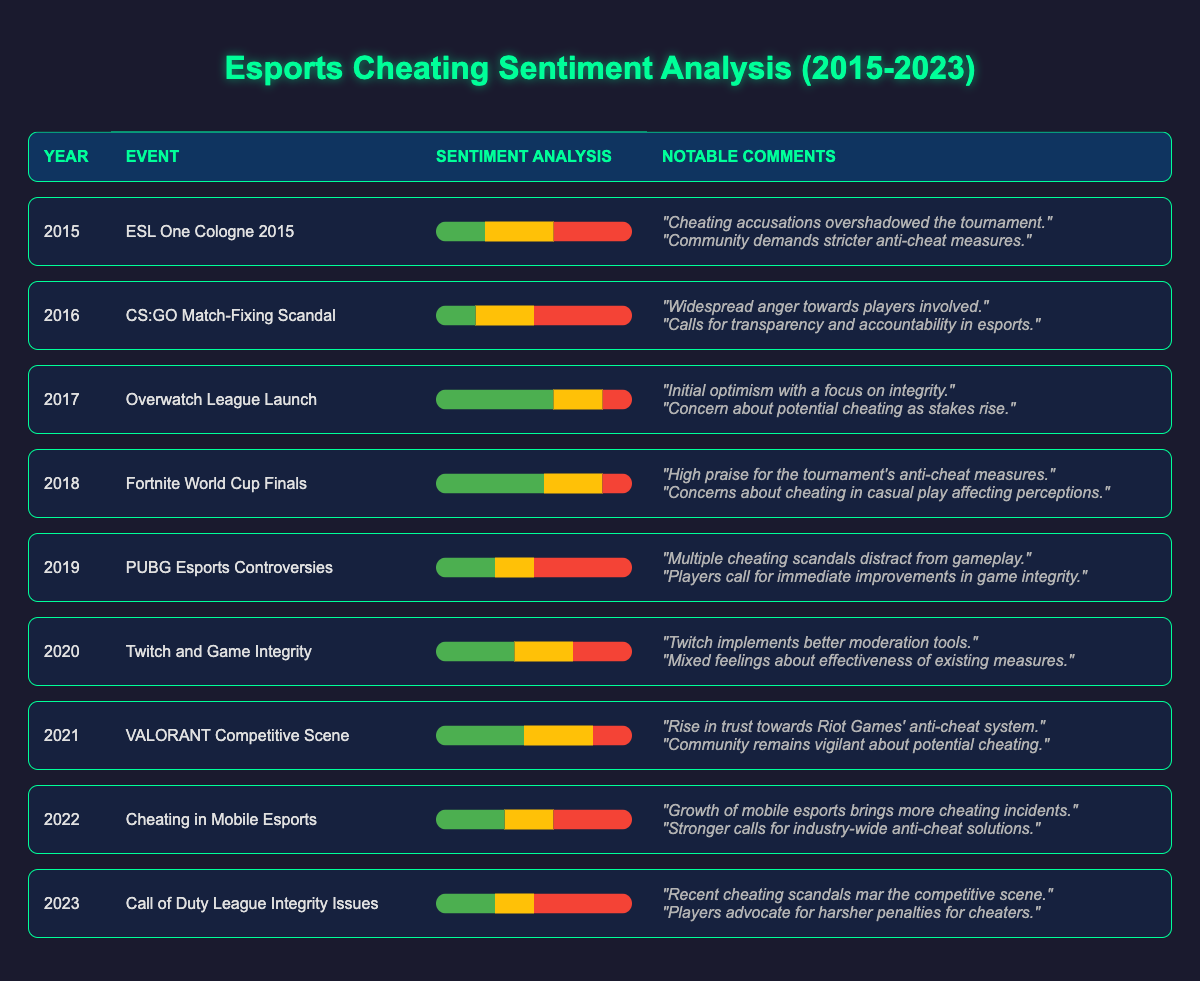What was the negative sentiment percentage in 2015? According to the table, the negative sentiment for the year 2015 (ESL One Cologne 2015) is explicitly stated as 40%.
Answer: 40% Which event in 2017 received the highest positive sentiment? The event in 2017 is the Overwatch League Launch, which had a positive sentiment of 60%, the highest in that year compared to other events.
Answer: Overwatch League Launch What was the overall trend in negative sentiment from 2015 to 2023? The negative sentiment increased from 40% in 2015, peaked to 50% in 2016, and fluctuated between 15% to 50%, ending at 50% in 2023.
Answer: It fluctuated, ending at 50% What is the average positive sentiment over the years from 2015 to 2023? To find the average, sum the positive sentiments: (25 + 20 + 60 + 55 + 30 + 40 + 45 + 35 + 30) = 370. There are 9 years total, so the average is 370 / 9 = approximately 41.11.
Answer: Approximately 41.11 Which year saw a decrease in positive sentiment compared to the previous year? In 2019, positive sentiment decreased to 30% from 55% in 2018, thus marking a decrease.
Answer: 2019 Did 2021 have a lower overall sentiment than 2022? Yes, in 2021 the overall sentiment's negative percentage (20% negative) combined with neutral and positive sentiments (45% positive and 35% neutral) shows higher positivity, compared to 2022 which had 40% negative sentiment.
Answer: Yes How many events from 2015 to 2023 had a negative sentiment above 40%? Observing the table, the years with negative sentiment above 40% are 2016 (50%), 2019 (50%), 2022 (40%), and 2023 (50%). This gives us a count of 4 events.
Answer: 4 events Which year had the lowest positive sentiment? The lowest positive sentiment can be found in 2016 with 20%.
Answer: 2016 What notable change occurred between 2018 and 2019 in terms of community sentiment? The sentiment shifted negatively from 55% positive and 15% negative in 2018 to 30% positive and 50% negative in 2019, indicating growing negativity.
Answer: A shift to greater negativity Was there a significant amount of neutral sentiment during the launch of the Overwatch League in 2017? Yes, in 2017 the neutral sentiment was 25%, which is significant compared to the overall sentiment, with a balance between positive and negative sentiments.
Answer: Yes From the event perspectives, which esports event resulted in extensive discussion about anti-cheat measures in the community? The notable comments from ESL One Cologne 2015 and subsequent events indicate there were significant discussions about anti-cheat measures, particularly after controversies arose.
Answer: ESL One Cologne 2015 